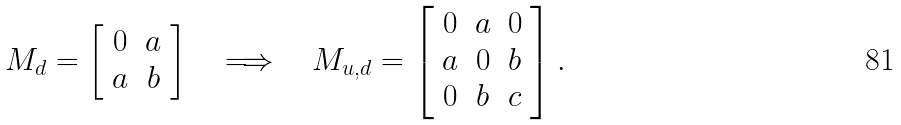<formula> <loc_0><loc_0><loc_500><loc_500>M _ { d } = \left [ \begin{array} { c c } { 0 } & { a } \\ { a } & { b } \end{array} \right ] \quad \Longrightarrow \quad M _ { u , d } = \left [ \begin{array} { c c c } { 0 } & { a } & { 0 } \\ { a } & { 0 } & { b } \\ { 0 } & { b } & { c } \end{array} \right ] .</formula> 